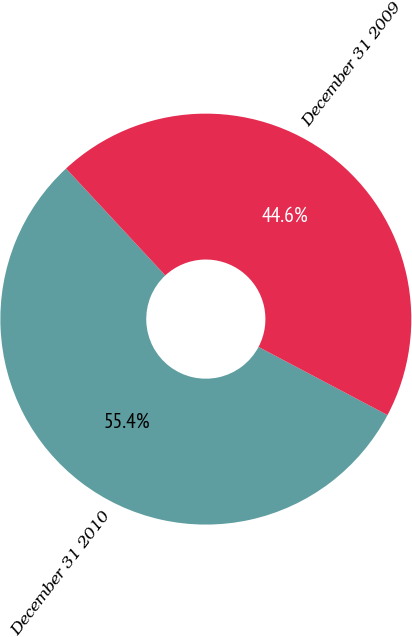Convert chart to OTSL. <chart><loc_0><loc_0><loc_500><loc_500><pie_chart><fcel>December 31 2010<fcel>December 31 2009<nl><fcel>55.36%<fcel>44.64%<nl></chart> 